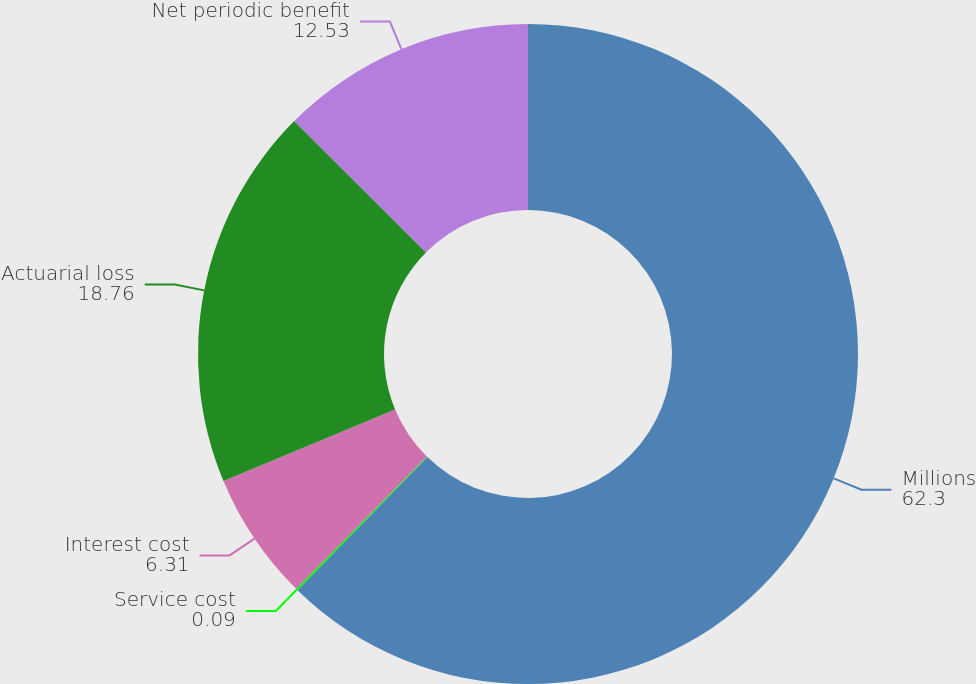Convert chart. <chart><loc_0><loc_0><loc_500><loc_500><pie_chart><fcel>Millions<fcel>Service cost<fcel>Interest cost<fcel>Actuarial loss<fcel>Net periodic benefit<nl><fcel>62.3%<fcel>0.09%<fcel>6.31%<fcel>18.76%<fcel>12.53%<nl></chart> 